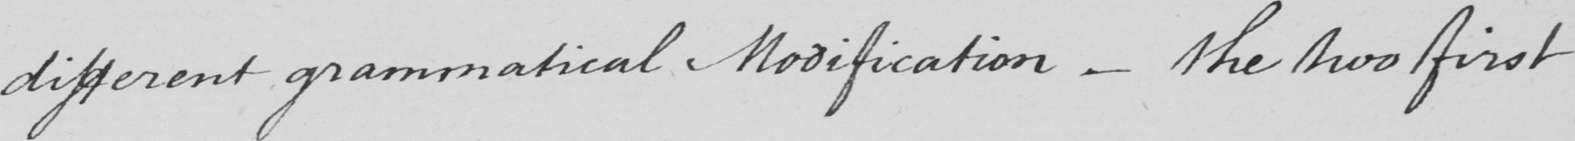Can you tell me what this handwritten text says? different grammatical Modification  _  the two first 